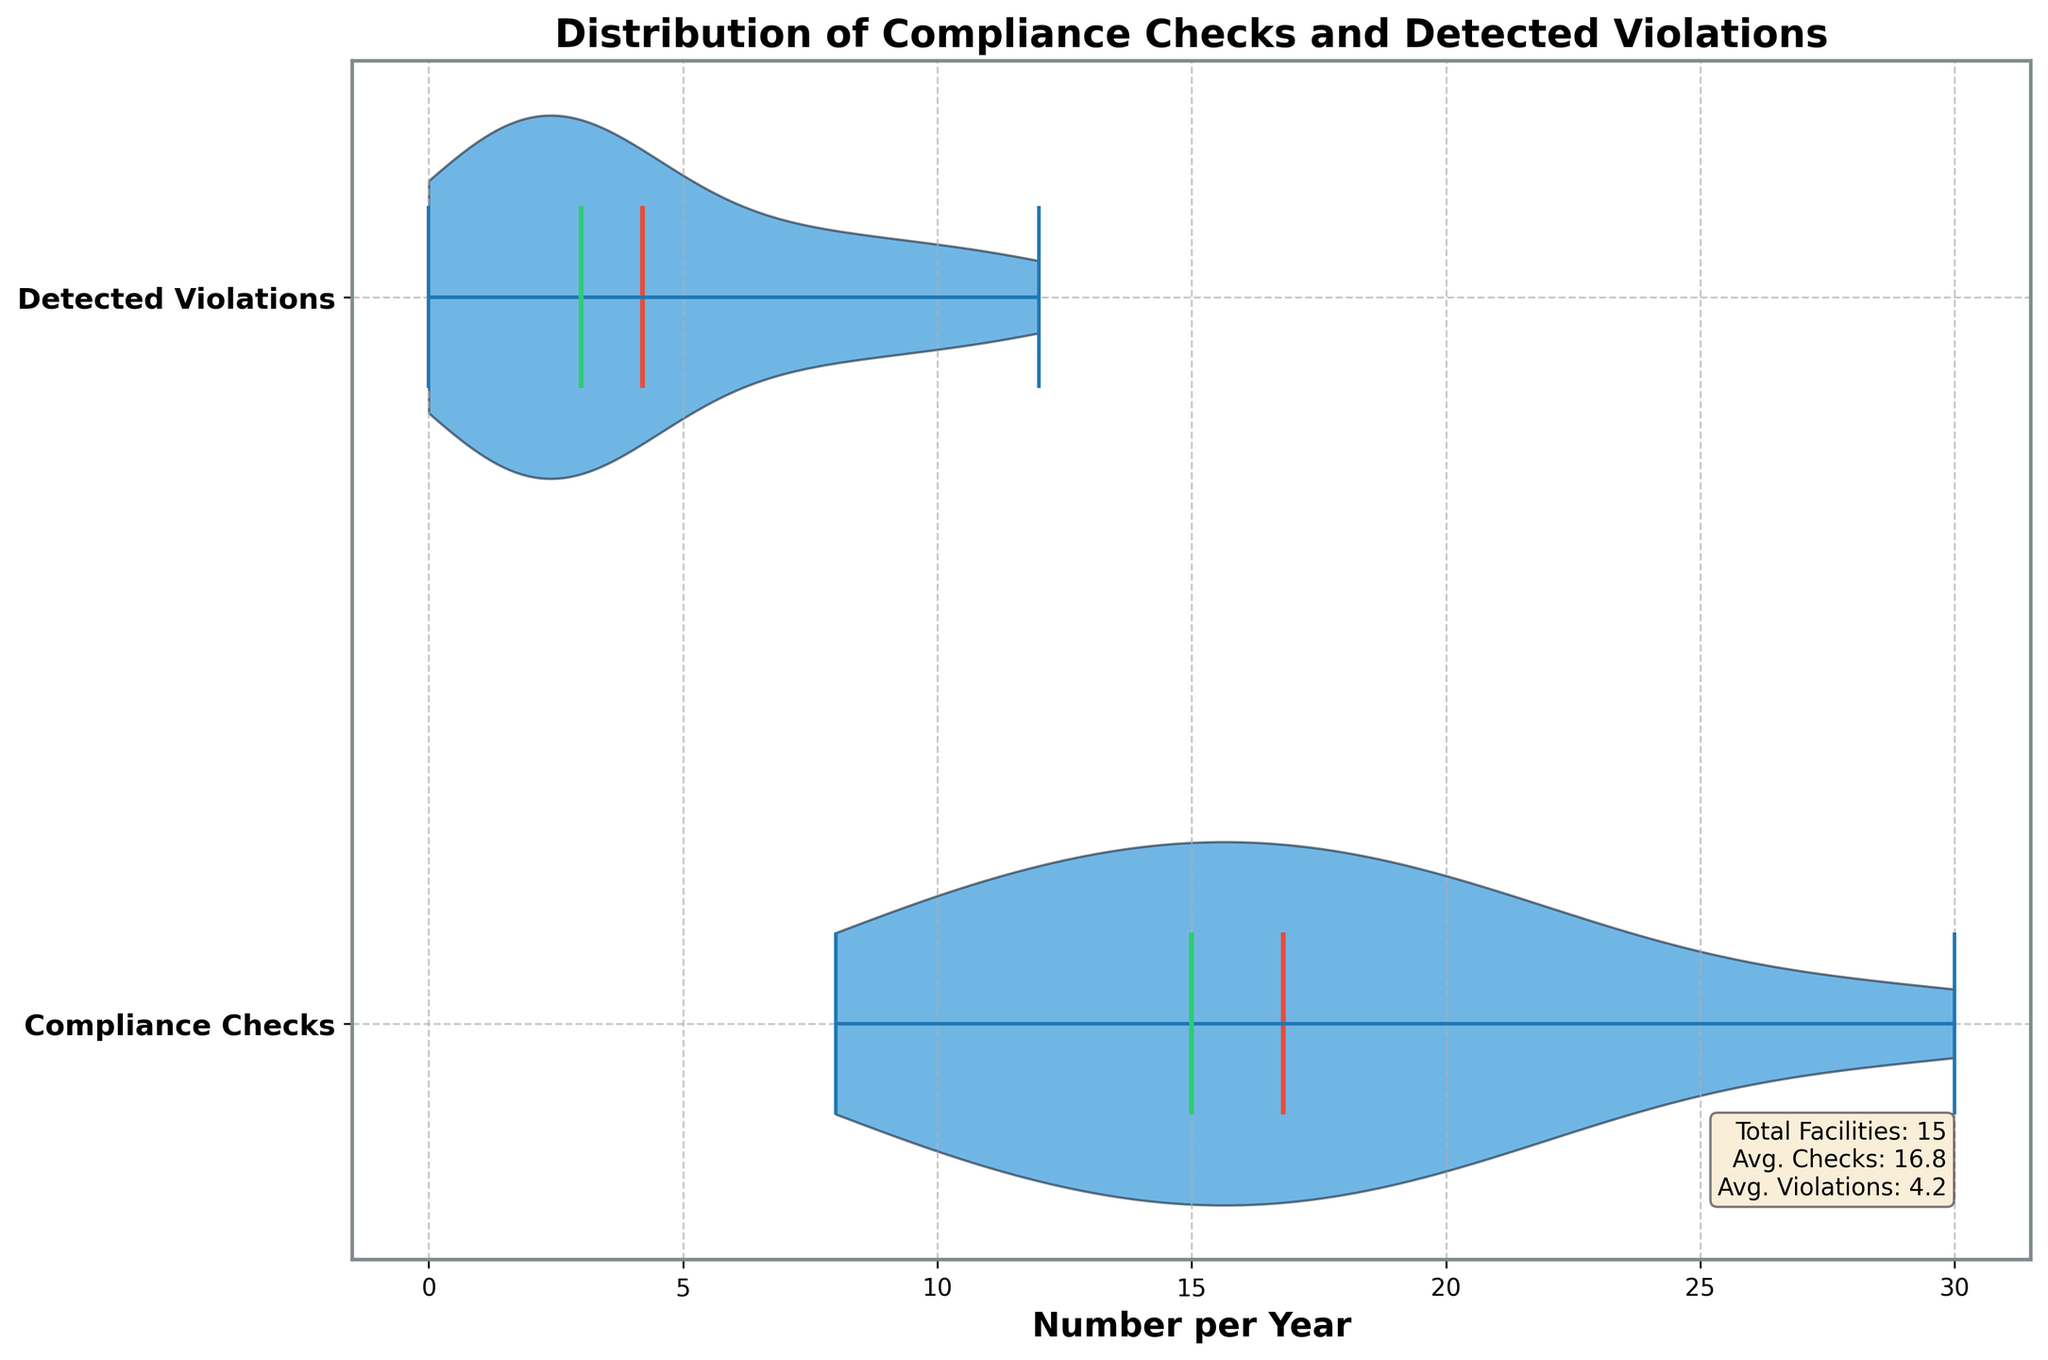How many groups are represented on the y-axis? The y-axis shows two distinct groups: Compliance Checks and Detected Violations. This can be visually confirmed by the two labels along the y-axis.
Answer: 2 What is the average number of compliance checks per facility per year? According to the text box in the figure, the average number of compliance checks is calculated and presented. This value is derived from the dataset comprising various facilities.
Answer: 17.4 What's the difference in the mean number of compliance checks and detected violations? The values of the means are provided in the text box in the figure. By identifying the mean compliance checks (17.4) and mean violations (3.9) and finding their difference, we get the desired result.
Answer: 13.5 Which group shows higher variability in its data distribution? From the shape and spread of the violin plots, we can observe that the Compliance Checks group has a wider distribution compared to Detected Violations, indicating higher variability.
Answer: Compliance Checks What color represents the median values in the figure? The median values are represented by a specific color in the violin plot. By observing the legend and violin plot, it is evident that the color green represents median values.
Answer: Green Which facility is likely contributing the highest to the average number of detected violations? Reviewing the dataset informs this question. Central Health System has a count of 12 detected violations, the highest in the dataset.
Answer: Central Health System Is the number of detected violations generally lower than compliance checks? Comparing the two violin plots visually, we can see that the distribution of detected violations lies significantly lower than that of compliance checks, highlighting that violations are generally fewer.
Answer: Yes What is the spread of the Compliance Checks data around the mean value? By looking at the violin plot for Compliance Checks, one can visually assess the data spread (width of the plot) around the mean line (red), suggesting how much data varies from the mean.
Answer: High spread around mean What's the title of the figure? The title is given at the top of the figure and provides context for the data being visualized. It is specifically noted in bold.
Answer: Distribution of Compliance Checks and Detected Violations Can you identify the average value of detected violations from the figure? According to the informational text box included in the figure, the average detected violations are explicitly stated.
Answer: 3.9 